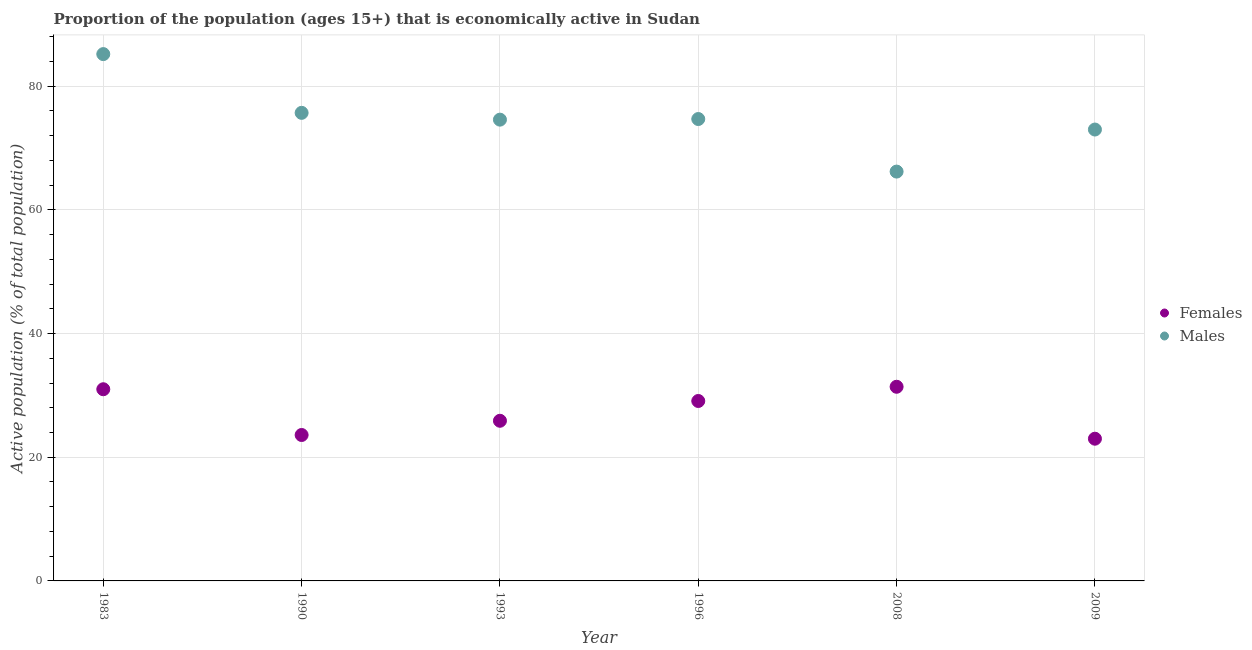How many different coloured dotlines are there?
Provide a succinct answer. 2. What is the percentage of economically active female population in 1996?
Your answer should be very brief. 29.1. Across all years, what is the maximum percentage of economically active female population?
Give a very brief answer. 31.4. In which year was the percentage of economically active female population maximum?
Give a very brief answer. 2008. What is the total percentage of economically active female population in the graph?
Provide a short and direct response. 164. What is the difference between the percentage of economically active male population in 1990 and the percentage of economically active female population in 1996?
Your answer should be very brief. 46.6. What is the average percentage of economically active female population per year?
Make the answer very short. 27.33. In the year 1983, what is the difference between the percentage of economically active female population and percentage of economically active male population?
Offer a terse response. -54.2. In how many years, is the percentage of economically active male population greater than 36 %?
Offer a terse response. 6. What is the ratio of the percentage of economically active female population in 2008 to that in 2009?
Offer a very short reply. 1.37. Is the percentage of economically active male population in 1983 less than that in 2008?
Your answer should be very brief. No. Is the difference between the percentage of economically active male population in 1983 and 2009 greater than the difference between the percentage of economically active female population in 1983 and 2009?
Your response must be concise. Yes. What is the difference between the highest and the second highest percentage of economically active female population?
Provide a short and direct response. 0.4. What is the difference between the highest and the lowest percentage of economically active male population?
Provide a short and direct response. 19. In how many years, is the percentage of economically active female population greater than the average percentage of economically active female population taken over all years?
Keep it short and to the point. 3. Does the percentage of economically active male population monotonically increase over the years?
Your answer should be compact. No. Is the percentage of economically active male population strictly less than the percentage of economically active female population over the years?
Ensure brevity in your answer.  No. How many years are there in the graph?
Provide a succinct answer. 6. What is the difference between two consecutive major ticks on the Y-axis?
Offer a terse response. 20. Are the values on the major ticks of Y-axis written in scientific E-notation?
Give a very brief answer. No. How many legend labels are there?
Your response must be concise. 2. How are the legend labels stacked?
Provide a short and direct response. Vertical. What is the title of the graph?
Your answer should be very brief. Proportion of the population (ages 15+) that is economically active in Sudan. What is the label or title of the Y-axis?
Give a very brief answer. Active population (% of total population). What is the Active population (% of total population) of Females in 1983?
Your answer should be very brief. 31. What is the Active population (% of total population) of Males in 1983?
Keep it short and to the point. 85.2. What is the Active population (% of total population) in Females in 1990?
Keep it short and to the point. 23.6. What is the Active population (% of total population) of Males in 1990?
Ensure brevity in your answer.  75.7. What is the Active population (% of total population) in Females in 1993?
Keep it short and to the point. 25.9. What is the Active population (% of total population) in Males in 1993?
Offer a very short reply. 74.6. What is the Active population (% of total population) of Females in 1996?
Provide a short and direct response. 29.1. What is the Active population (% of total population) in Males in 1996?
Give a very brief answer. 74.7. What is the Active population (% of total population) of Females in 2008?
Ensure brevity in your answer.  31.4. What is the Active population (% of total population) in Males in 2008?
Provide a short and direct response. 66.2. What is the Active population (% of total population) of Males in 2009?
Make the answer very short. 73. Across all years, what is the maximum Active population (% of total population) in Females?
Keep it short and to the point. 31.4. Across all years, what is the maximum Active population (% of total population) of Males?
Make the answer very short. 85.2. Across all years, what is the minimum Active population (% of total population) of Males?
Offer a terse response. 66.2. What is the total Active population (% of total population) of Females in the graph?
Keep it short and to the point. 164. What is the total Active population (% of total population) in Males in the graph?
Your response must be concise. 449.4. What is the difference between the Active population (% of total population) in Males in 1983 and that in 1993?
Give a very brief answer. 10.6. What is the difference between the Active population (% of total population) in Males in 1983 and that in 1996?
Your answer should be compact. 10.5. What is the difference between the Active population (% of total population) of Males in 1983 and that in 2008?
Offer a terse response. 19. What is the difference between the Active population (% of total population) of Females in 1983 and that in 2009?
Keep it short and to the point. 8. What is the difference between the Active population (% of total population) of Females in 1990 and that in 1993?
Provide a succinct answer. -2.3. What is the difference between the Active population (% of total population) in Males in 1990 and that in 1993?
Make the answer very short. 1.1. What is the difference between the Active population (% of total population) of Males in 1990 and that in 1996?
Provide a succinct answer. 1. What is the difference between the Active population (% of total population) of Females in 1990 and that in 2008?
Ensure brevity in your answer.  -7.8. What is the difference between the Active population (% of total population) of Females in 1993 and that in 2008?
Make the answer very short. -5.5. What is the difference between the Active population (% of total population) of Males in 1993 and that in 2008?
Offer a terse response. 8.4. What is the difference between the Active population (% of total population) of Females in 1993 and that in 2009?
Offer a terse response. 2.9. What is the difference between the Active population (% of total population) of Males in 1996 and that in 2008?
Provide a short and direct response. 8.5. What is the difference between the Active population (% of total population) in Males in 1996 and that in 2009?
Your answer should be compact. 1.7. What is the difference between the Active population (% of total population) of Females in 2008 and that in 2009?
Make the answer very short. 8.4. What is the difference between the Active population (% of total population) of Females in 1983 and the Active population (% of total population) of Males in 1990?
Make the answer very short. -44.7. What is the difference between the Active population (% of total population) in Females in 1983 and the Active population (% of total population) in Males in 1993?
Provide a short and direct response. -43.6. What is the difference between the Active population (% of total population) in Females in 1983 and the Active population (% of total population) in Males in 1996?
Keep it short and to the point. -43.7. What is the difference between the Active population (% of total population) in Females in 1983 and the Active population (% of total population) in Males in 2008?
Your response must be concise. -35.2. What is the difference between the Active population (% of total population) in Females in 1983 and the Active population (% of total population) in Males in 2009?
Your answer should be very brief. -42. What is the difference between the Active population (% of total population) of Females in 1990 and the Active population (% of total population) of Males in 1993?
Your response must be concise. -51. What is the difference between the Active population (% of total population) in Females in 1990 and the Active population (% of total population) in Males in 1996?
Your answer should be very brief. -51.1. What is the difference between the Active population (% of total population) in Females in 1990 and the Active population (% of total population) in Males in 2008?
Ensure brevity in your answer.  -42.6. What is the difference between the Active population (% of total population) in Females in 1990 and the Active population (% of total population) in Males in 2009?
Offer a very short reply. -49.4. What is the difference between the Active population (% of total population) of Females in 1993 and the Active population (% of total population) of Males in 1996?
Your answer should be compact. -48.8. What is the difference between the Active population (% of total population) in Females in 1993 and the Active population (% of total population) in Males in 2008?
Your response must be concise. -40.3. What is the difference between the Active population (% of total population) in Females in 1993 and the Active population (% of total population) in Males in 2009?
Provide a short and direct response. -47.1. What is the difference between the Active population (% of total population) of Females in 1996 and the Active population (% of total population) of Males in 2008?
Provide a succinct answer. -37.1. What is the difference between the Active population (% of total population) in Females in 1996 and the Active population (% of total population) in Males in 2009?
Your answer should be very brief. -43.9. What is the difference between the Active population (% of total population) in Females in 2008 and the Active population (% of total population) in Males in 2009?
Offer a terse response. -41.6. What is the average Active population (% of total population) in Females per year?
Make the answer very short. 27.33. What is the average Active population (% of total population) of Males per year?
Ensure brevity in your answer.  74.9. In the year 1983, what is the difference between the Active population (% of total population) of Females and Active population (% of total population) of Males?
Your answer should be very brief. -54.2. In the year 1990, what is the difference between the Active population (% of total population) in Females and Active population (% of total population) in Males?
Offer a very short reply. -52.1. In the year 1993, what is the difference between the Active population (% of total population) of Females and Active population (% of total population) of Males?
Your answer should be compact. -48.7. In the year 1996, what is the difference between the Active population (% of total population) of Females and Active population (% of total population) of Males?
Your response must be concise. -45.6. In the year 2008, what is the difference between the Active population (% of total population) of Females and Active population (% of total population) of Males?
Your answer should be compact. -34.8. What is the ratio of the Active population (% of total population) of Females in 1983 to that in 1990?
Your answer should be compact. 1.31. What is the ratio of the Active population (% of total population) in Males in 1983 to that in 1990?
Keep it short and to the point. 1.13. What is the ratio of the Active population (% of total population) of Females in 1983 to that in 1993?
Offer a very short reply. 1.2. What is the ratio of the Active population (% of total population) in Males in 1983 to that in 1993?
Your answer should be compact. 1.14. What is the ratio of the Active population (% of total population) in Females in 1983 to that in 1996?
Your answer should be compact. 1.07. What is the ratio of the Active population (% of total population) in Males in 1983 to that in 1996?
Your response must be concise. 1.14. What is the ratio of the Active population (% of total population) of Females in 1983 to that in 2008?
Offer a very short reply. 0.99. What is the ratio of the Active population (% of total population) of Males in 1983 to that in 2008?
Give a very brief answer. 1.29. What is the ratio of the Active population (% of total population) in Females in 1983 to that in 2009?
Your answer should be compact. 1.35. What is the ratio of the Active population (% of total population) in Males in 1983 to that in 2009?
Your answer should be very brief. 1.17. What is the ratio of the Active population (% of total population) of Females in 1990 to that in 1993?
Make the answer very short. 0.91. What is the ratio of the Active population (% of total population) of Males in 1990 to that in 1993?
Offer a very short reply. 1.01. What is the ratio of the Active population (% of total population) of Females in 1990 to that in 1996?
Give a very brief answer. 0.81. What is the ratio of the Active population (% of total population) of Males in 1990 to that in 1996?
Provide a short and direct response. 1.01. What is the ratio of the Active population (% of total population) of Females in 1990 to that in 2008?
Make the answer very short. 0.75. What is the ratio of the Active population (% of total population) in Males in 1990 to that in 2008?
Your answer should be compact. 1.14. What is the ratio of the Active population (% of total population) of Females in 1990 to that in 2009?
Your answer should be compact. 1.03. What is the ratio of the Active population (% of total population) in Females in 1993 to that in 1996?
Give a very brief answer. 0.89. What is the ratio of the Active population (% of total population) in Females in 1993 to that in 2008?
Make the answer very short. 0.82. What is the ratio of the Active population (% of total population) in Males in 1993 to that in 2008?
Your response must be concise. 1.13. What is the ratio of the Active population (% of total population) in Females in 1993 to that in 2009?
Ensure brevity in your answer.  1.13. What is the ratio of the Active population (% of total population) of Males in 1993 to that in 2009?
Provide a short and direct response. 1.02. What is the ratio of the Active population (% of total population) of Females in 1996 to that in 2008?
Your answer should be compact. 0.93. What is the ratio of the Active population (% of total population) in Males in 1996 to that in 2008?
Offer a very short reply. 1.13. What is the ratio of the Active population (% of total population) in Females in 1996 to that in 2009?
Ensure brevity in your answer.  1.27. What is the ratio of the Active population (% of total population) of Males in 1996 to that in 2009?
Your answer should be very brief. 1.02. What is the ratio of the Active population (% of total population) in Females in 2008 to that in 2009?
Offer a very short reply. 1.37. What is the ratio of the Active population (% of total population) of Males in 2008 to that in 2009?
Ensure brevity in your answer.  0.91. What is the difference between the highest and the second highest Active population (% of total population) in Females?
Make the answer very short. 0.4. 